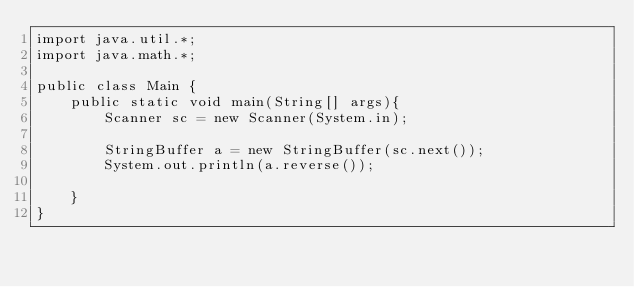Convert code to text. <code><loc_0><loc_0><loc_500><loc_500><_Java_>import java.util.*;
import java.math.*;

public class Main {
    public static void main(String[] args){
        Scanner sc = new Scanner(System.in);

        StringBuffer a = new StringBuffer(sc.next());
        System.out.println(a.reverse());

    }
}</code> 